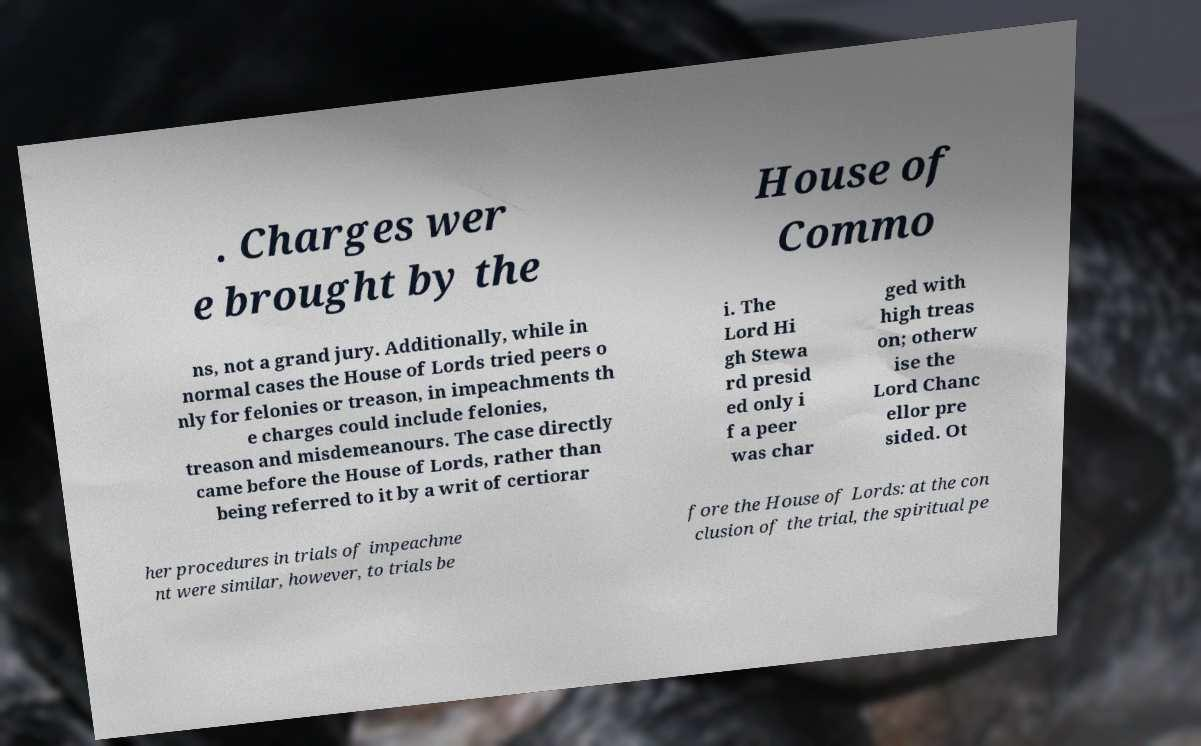Please identify and transcribe the text found in this image. . Charges wer e brought by the House of Commo ns, not a grand jury. Additionally, while in normal cases the House of Lords tried peers o nly for felonies or treason, in impeachments th e charges could include felonies, treason and misdemeanours. The case directly came before the House of Lords, rather than being referred to it by a writ of certiorar i. The Lord Hi gh Stewa rd presid ed only i f a peer was char ged with high treas on; otherw ise the Lord Chanc ellor pre sided. Ot her procedures in trials of impeachme nt were similar, however, to trials be fore the House of Lords: at the con clusion of the trial, the spiritual pe 